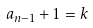<formula> <loc_0><loc_0><loc_500><loc_500>a _ { n - 1 } + 1 = k</formula> 